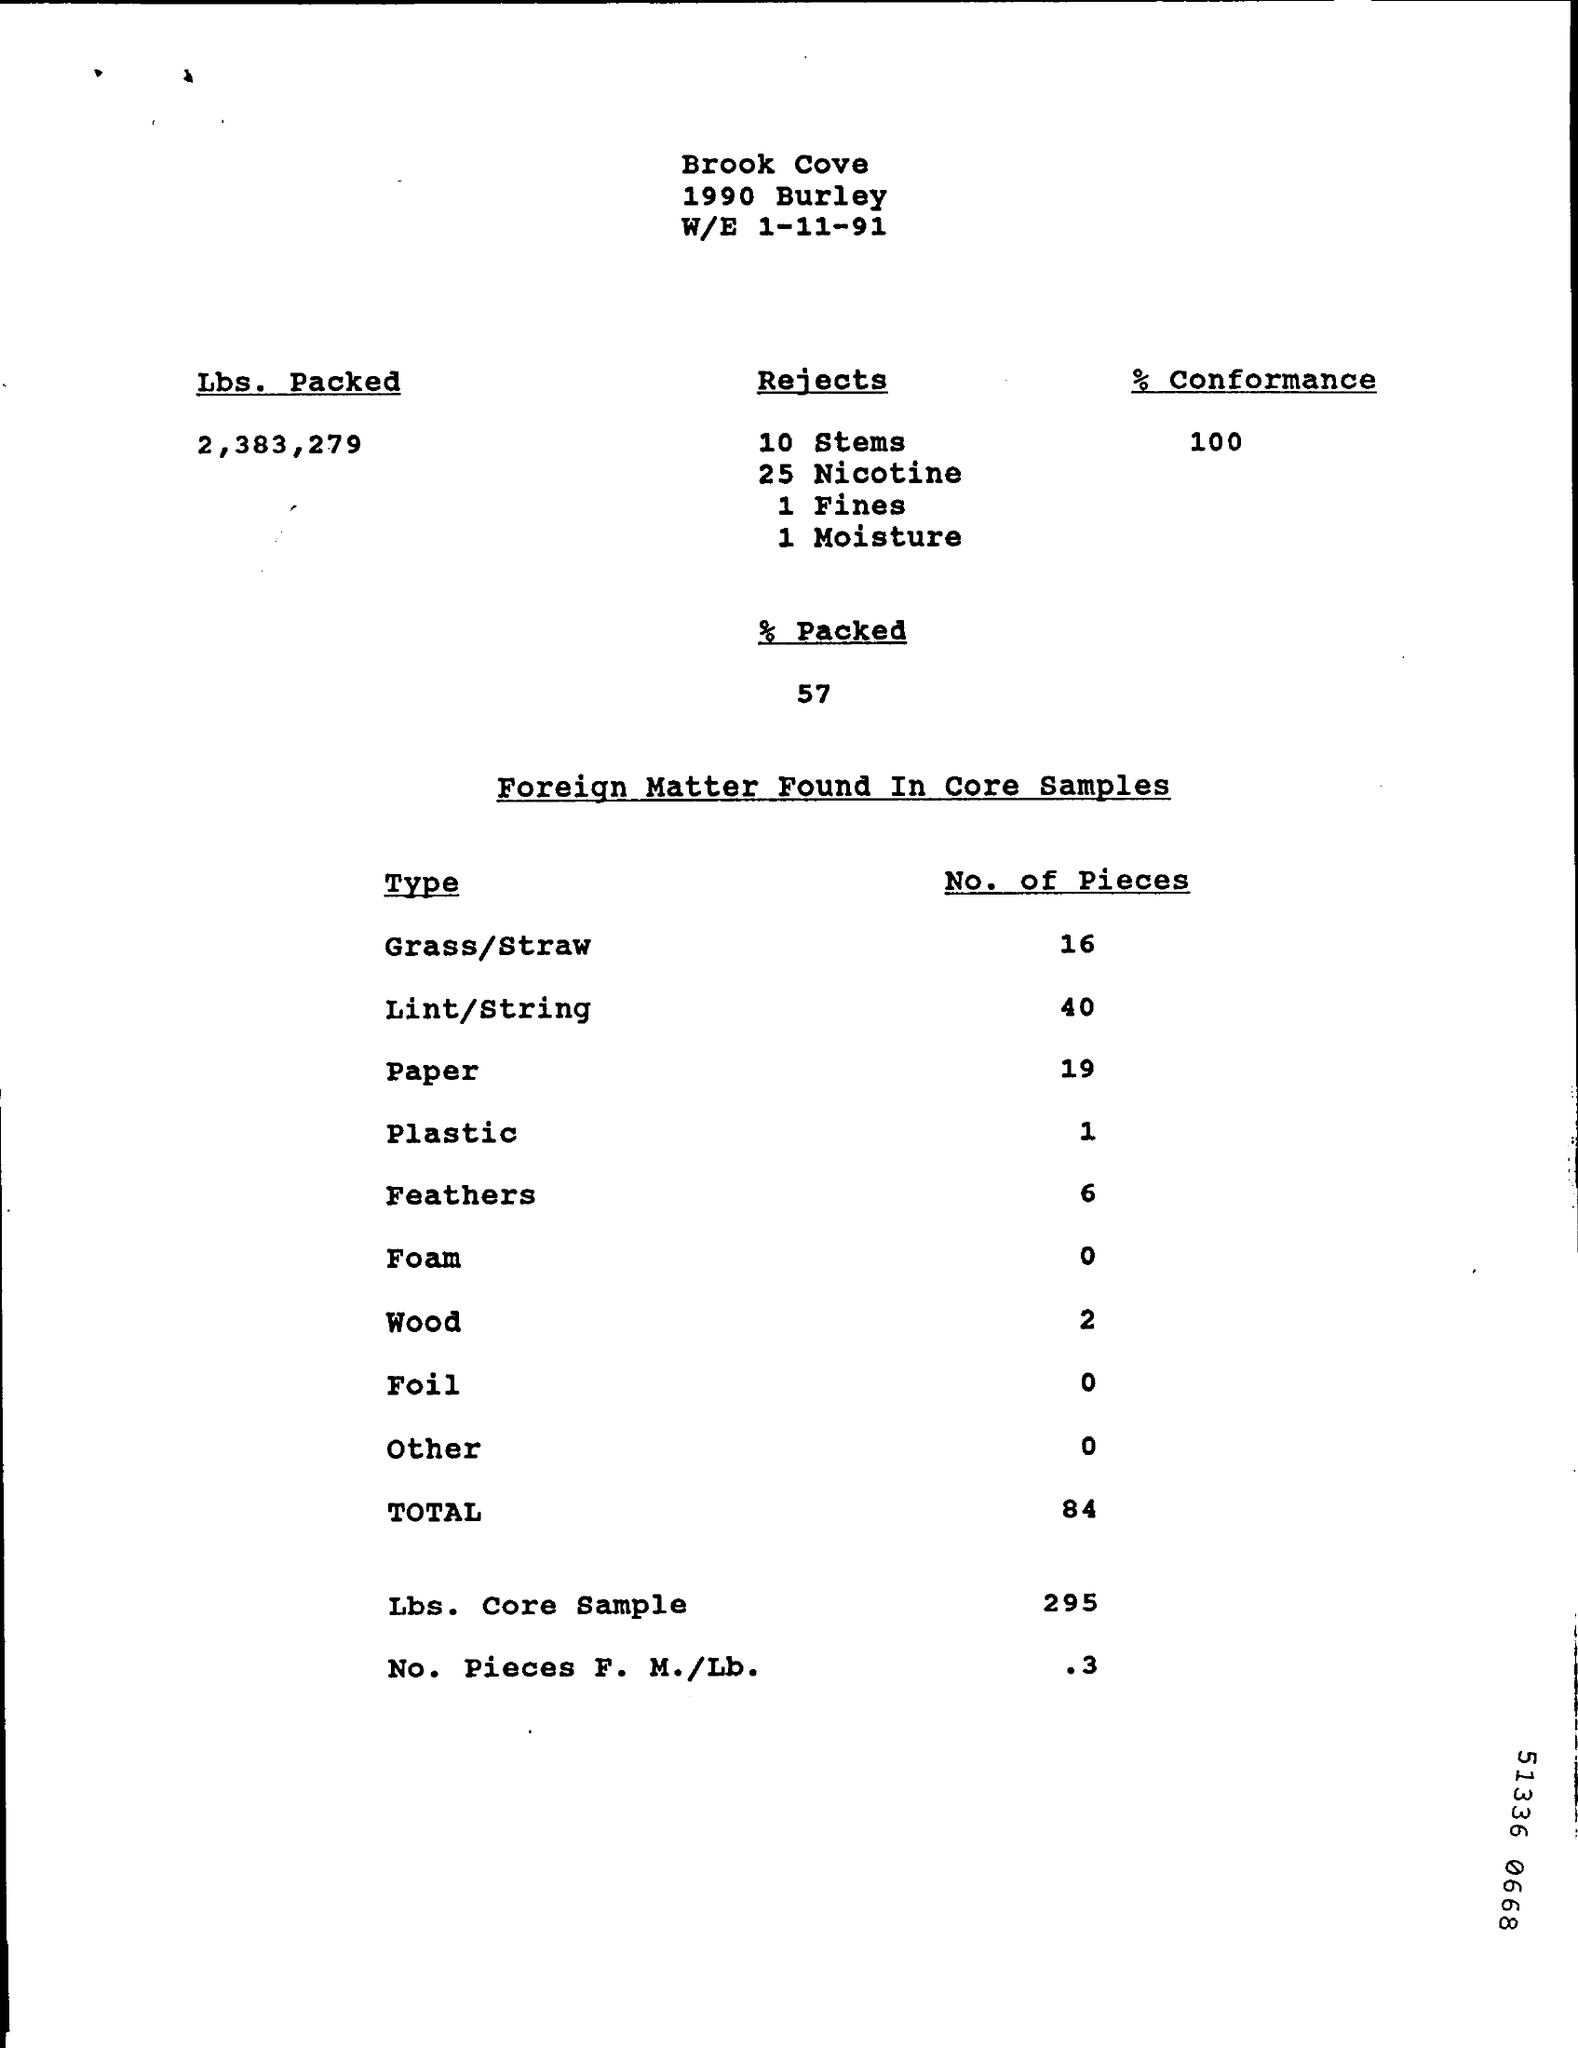Give some essential details in this illustration. Six feathers were found in the samples. Out of the total number of pounds packed, a certain number of stems were rejected. 